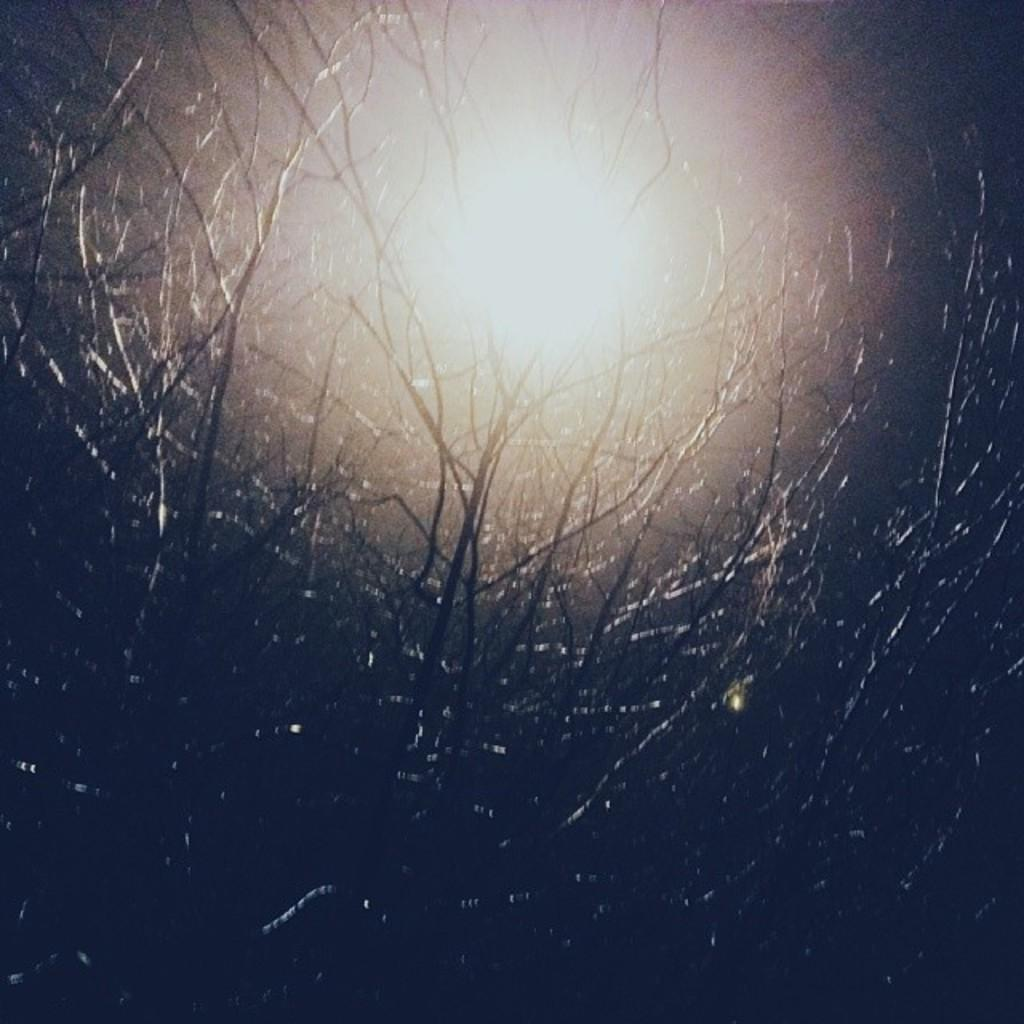What type of vegetation can be seen in the image? There are trees in the image. What celestial body is visible in the image? The sun is visible in the image. What type of bells can be heard ringing in the image? There are no bells present in the image, and therefore no sound can be heard. 